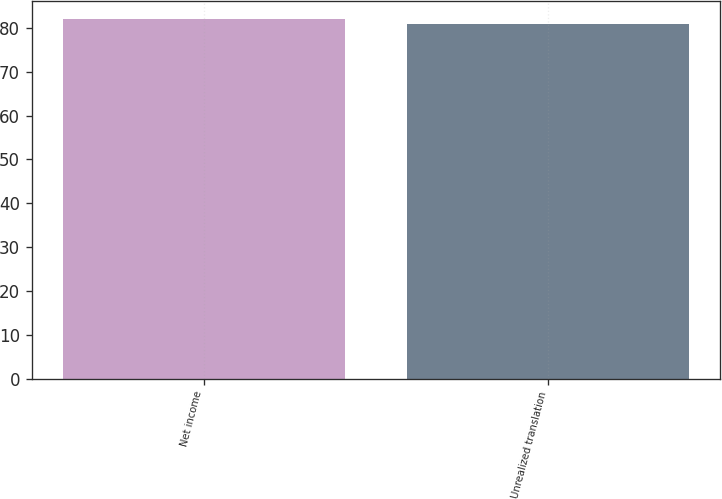<chart> <loc_0><loc_0><loc_500><loc_500><bar_chart><fcel>Net income<fcel>Unrealized translation<nl><fcel>82<fcel>81<nl></chart> 